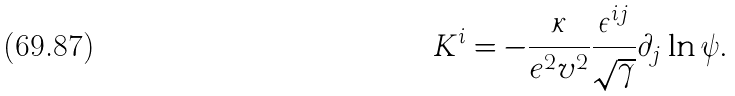<formula> <loc_0><loc_0><loc_500><loc_500>K ^ { i } = - \frac { \kappa } { e ^ { 2 } v ^ { 2 } } \frac { \epsilon ^ { i j } } { \sqrt { \gamma } } \partial _ { j } \ln \psi .</formula> 